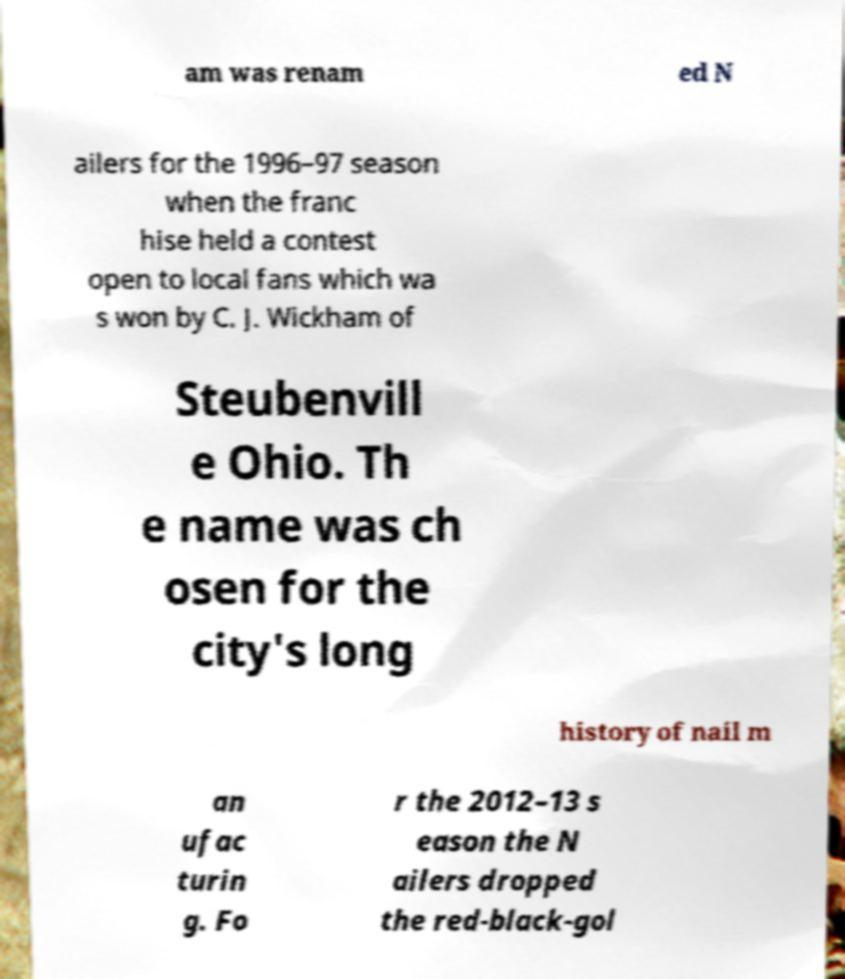Please identify and transcribe the text found in this image. am was renam ed N ailers for the 1996–97 season when the franc hise held a contest open to local fans which wa s won by C. J. Wickham of Steubenvill e Ohio. Th e name was ch osen for the city's long history of nail m an ufac turin g. Fo r the 2012–13 s eason the N ailers dropped the red-black-gol 